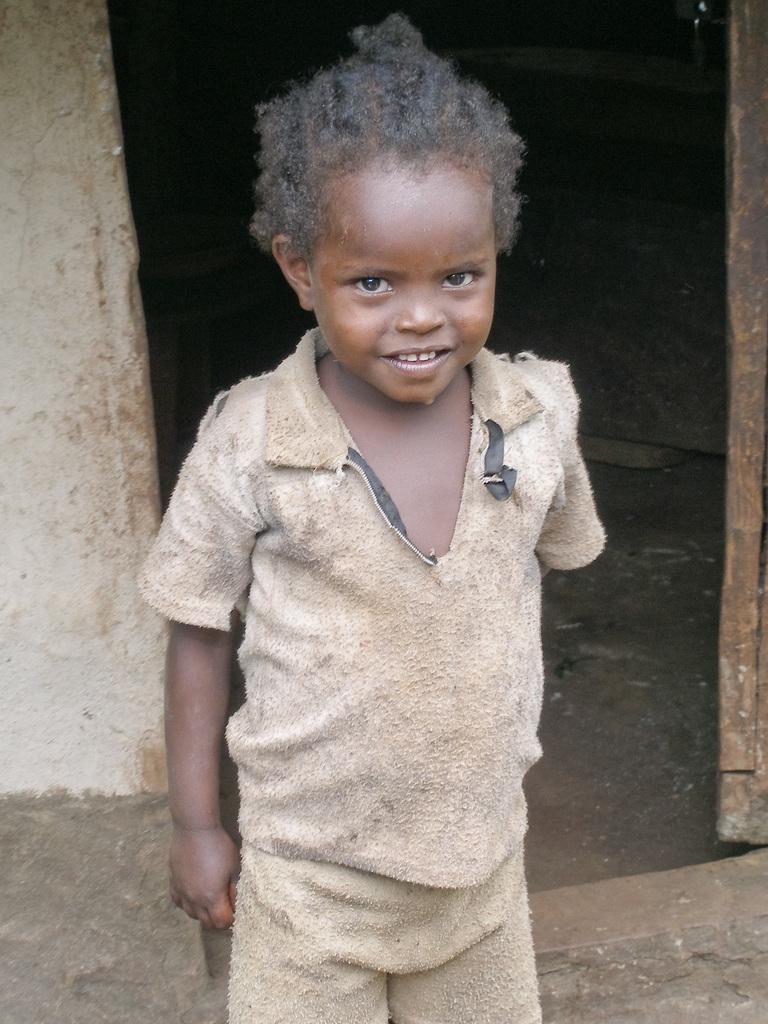In one or two sentences, can you explain what this image depicts? In this picture we can see a child standing and smiling, wall, ground and in the background it is dark. 